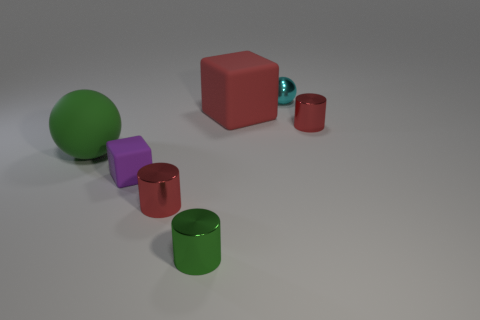There is a big green matte thing that is on the left side of the tiny green metal thing; are there any purple blocks behind it?
Your answer should be very brief. No. How big is the rubber cube that is right of the tiny red metallic cylinder that is on the left side of the rubber object behind the large green rubber sphere?
Offer a terse response. Large. What is the material of the small red thing that is in front of the big matte object on the left side of the red rubber object?
Ensure brevity in your answer.  Metal. Are there any small gray things that have the same shape as the tiny purple thing?
Your answer should be very brief. No. The purple object is what shape?
Offer a very short reply. Cube. What material is the purple block that is behind the small red metal thing that is on the left side of the metal cylinder behind the tiny purple object made of?
Offer a terse response. Rubber. Is the number of small green metal things that are in front of the purple thing greater than the number of tiny green metallic objects?
Provide a succinct answer. No. What material is the purple thing that is the same size as the cyan thing?
Provide a succinct answer. Rubber. Is there a cylinder that has the same size as the cyan ball?
Ensure brevity in your answer.  Yes. There is a rubber thing in front of the green rubber object; what size is it?
Make the answer very short. Small. 